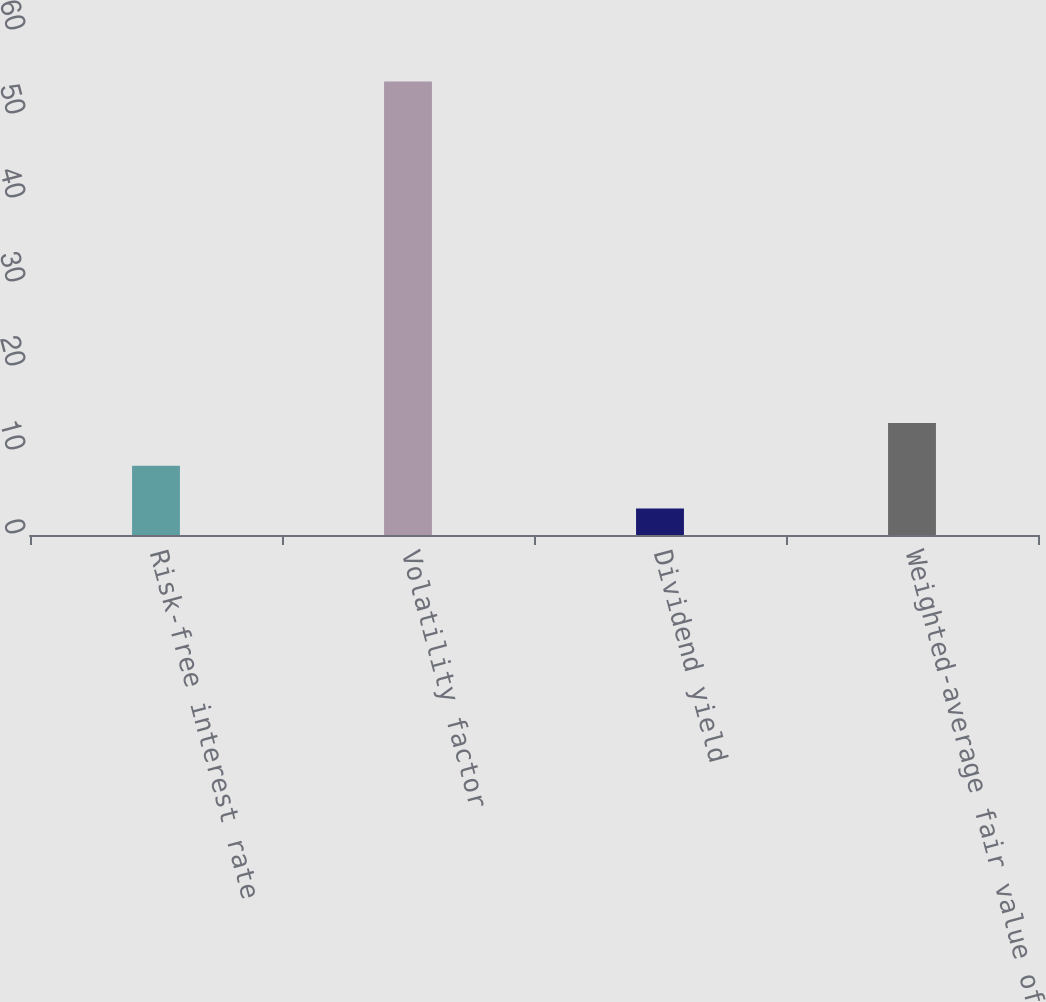<chart> <loc_0><loc_0><loc_500><loc_500><bar_chart><fcel>Risk-free interest rate<fcel>Volatility factor<fcel>Dividend yield<fcel>Weighted-average fair value of<nl><fcel>8.24<fcel>54<fcel>3.16<fcel>13.32<nl></chart> 